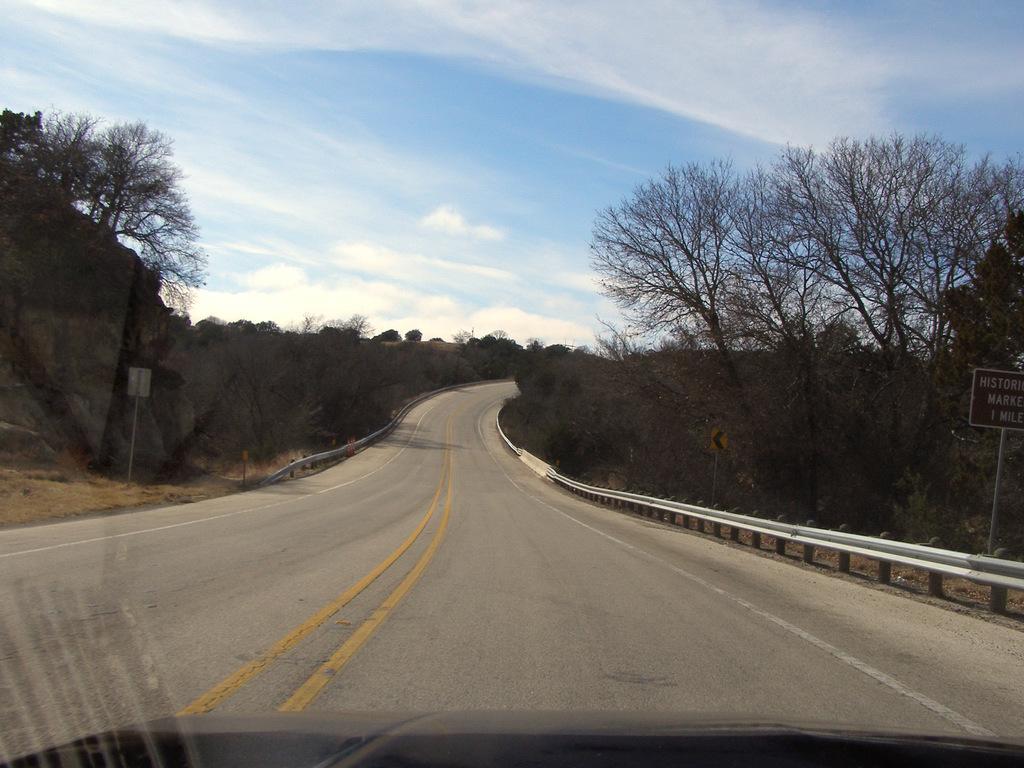How would you summarize this image in a sentence or two? In this image I can see a road and both side of this road I can see number of trees, few poles, few boards and on one board I can see something is written. In the background I can see the sky and clouds. 